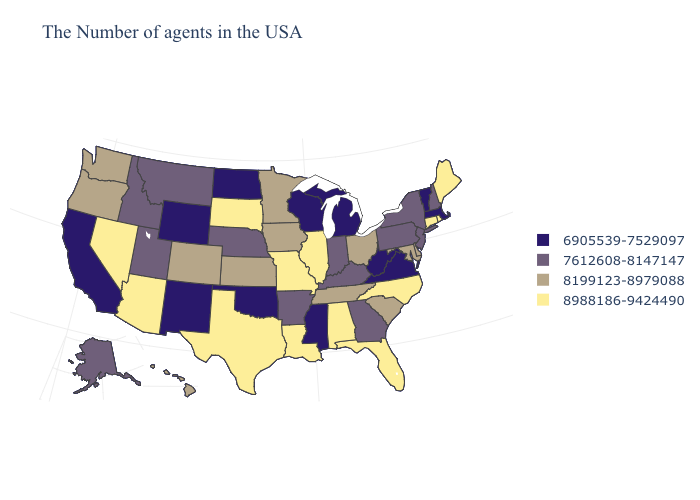What is the value of Virginia?
Concise answer only. 6905539-7529097. Name the states that have a value in the range 8988186-9424490?
Short answer required. Maine, Rhode Island, Connecticut, North Carolina, Florida, Alabama, Illinois, Louisiana, Missouri, Texas, South Dakota, Arizona, Nevada. What is the lowest value in the Northeast?
Short answer required. 6905539-7529097. Does California have the highest value in the West?
Answer briefly. No. Among the states that border Kentucky , which have the lowest value?
Answer briefly. Virginia, West Virginia. Name the states that have a value in the range 6905539-7529097?
Quick response, please. Massachusetts, Vermont, Virginia, West Virginia, Michigan, Wisconsin, Mississippi, Oklahoma, North Dakota, Wyoming, New Mexico, California. Name the states that have a value in the range 6905539-7529097?
Quick response, please. Massachusetts, Vermont, Virginia, West Virginia, Michigan, Wisconsin, Mississippi, Oklahoma, North Dakota, Wyoming, New Mexico, California. Name the states that have a value in the range 8988186-9424490?
Be succinct. Maine, Rhode Island, Connecticut, North Carolina, Florida, Alabama, Illinois, Louisiana, Missouri, Texas, South Dakota, Arizona, Nevada. What is the value of Vermont?
Concise answer only. 6905539-7529097. Name the states that have a value in the range 8988186-9424490?
Answer briefly. Maine, Rhode Island, Connecticut, North Carolina, Florida, Alabama, Illinois, Louisiana, Missouri, Texas, South Dakota, Arizona, Nevada. What is the value of Mississippi?
Short answer required. 6905539-7529097. What is the lowest value in states that border Louisiana?
Quick response, please. 6905539-7529097. Does Colorado have a lower value than Tennessee?
Keep it brief. No. What is the lowest value in the USA?
Keep it brief. 6905539-7529097. Name the states that have a value in the range 7612608-8147147?
Write a very short answer. New Hampshire, New York, New Jersey, Pennsylvania, Georgia, Kentucky, Indiana, Arkansas, Nebraska, Utah, Montana, Idaho, Alaska. 